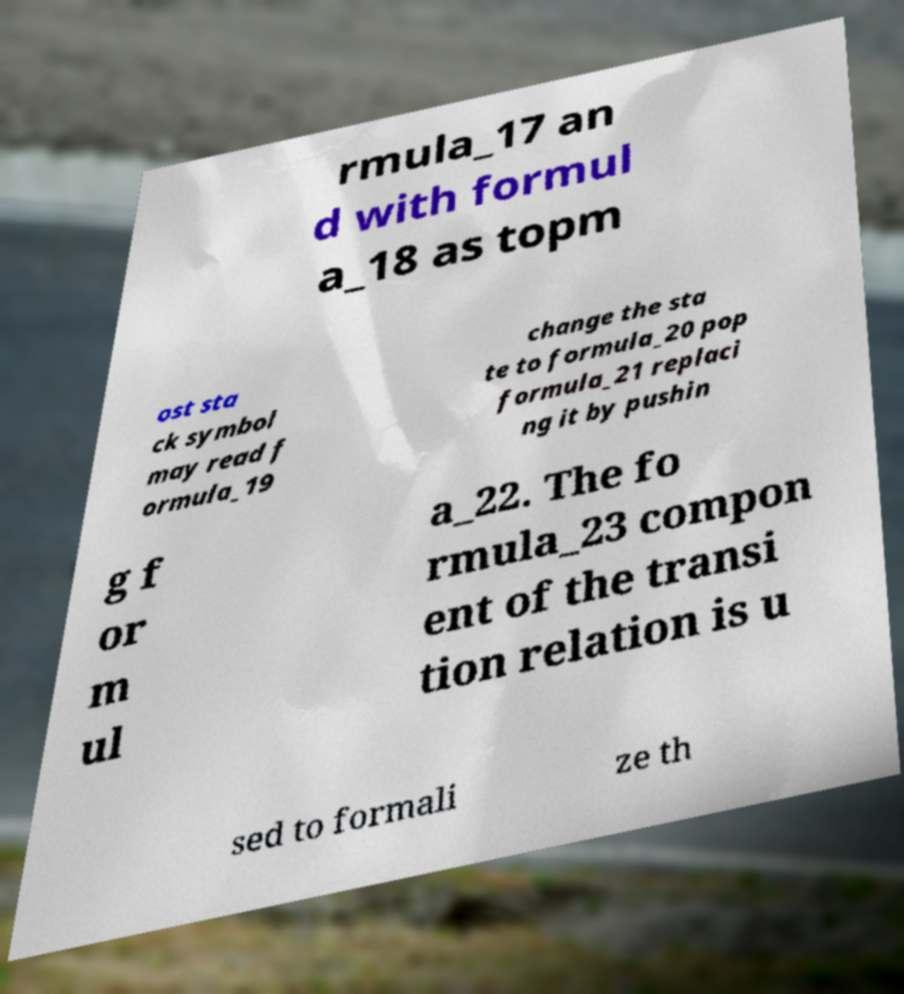Please identify and transcribe the text found in this image. rmula_17 an d with formul a_18 as topm ost sta ck symbol may read f ormula_19 change the sta te to formula_20 pop formula_21 replaci ng it by pushin g f or m ul a_22. The fo rmula_23 compon ent of the transi tion relation is u sed to formali ze th 